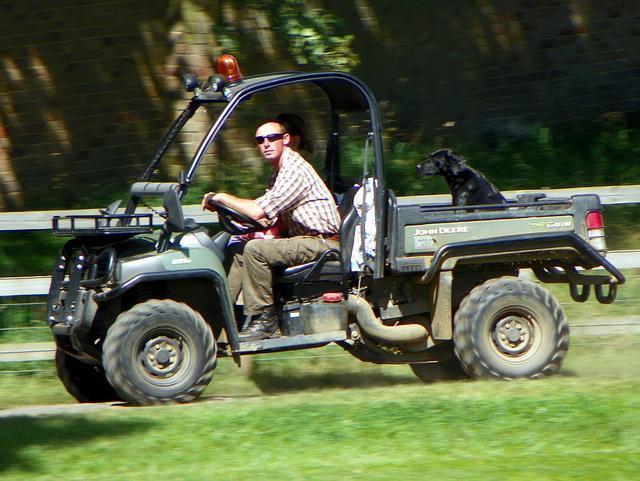Why is the dog in the back?
Select the accurate answer and provide justification: `Answer: choice
Rationale: srationale.`
Options: Broken truck, was bad, no room, snuck on. Answer: no room.
Rationale: The person knows the dog is there. there was probably no room in the front. 